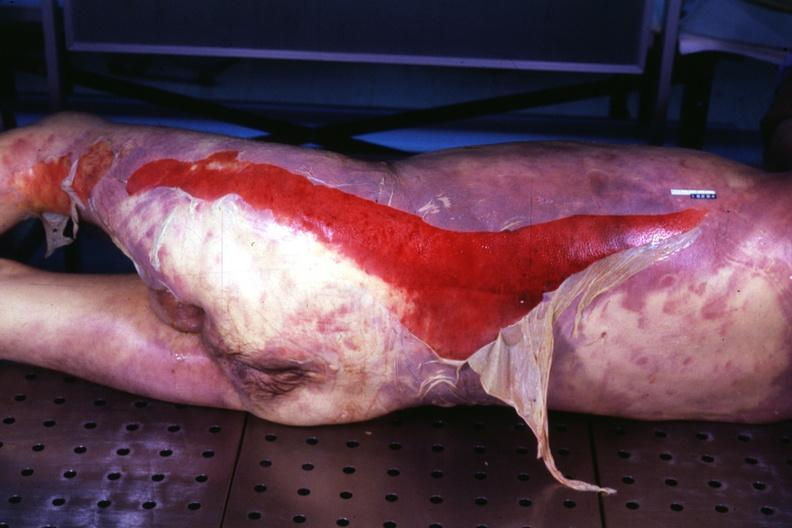what does this image show?
Answer the question using a single word or phrase. Portion of body with extensive skin desquamation same as in 907 